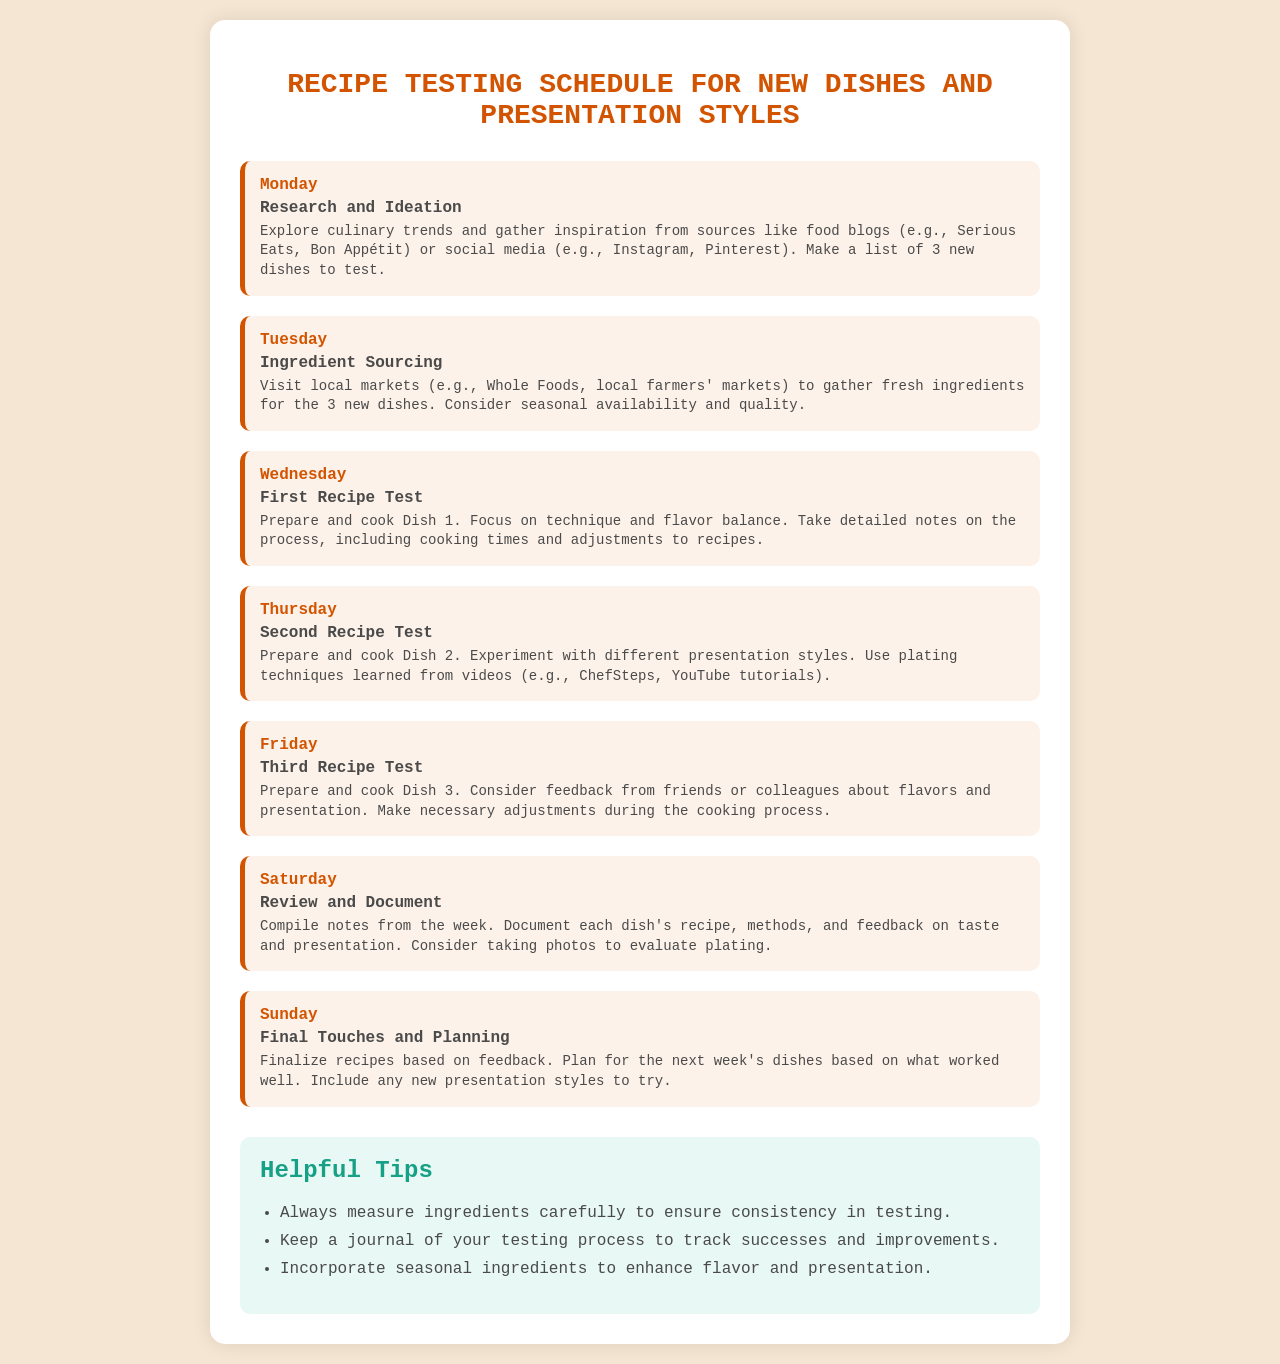What is the activity for Monday? Monday's activity is listed as "Research and Ideation," where culinary trends are explored and new dishes are planned.
Answer: Research and Ideation Which day is dedicated to sourcing ingredients? Ingredient Sourcing is scheduled for Tuesday, where fresh ingredients for new dishes are gathered.
Answer: Tuesday How many new dishes are planned for testing? The document specifies that a list of 3 new dishes is to be tested throughout the week.
Answer: 3 What is the focus on Wednesday's recipe test? The first recipe test on Wednesday focuses on technique and flavor balance for Dish 1.
Answer: Technique and flavor balance What happens on Saturday? Saturday is for reviewing and documenting notes from the week's recipe tests.
Answer: Review and Document What is the purpose of the Sunday activity? Sunday involves finalizing recipes based on feedback and planning for the next week's dishes.
Answer: Final Touches and Planning Which helpful tip emphasizes measuring? The tip advises that ingredients should be measured carefully to ensure consistency during testing.
Answer: Measure ingredients carefully What should be included when documenting each dish? The documentation should include the recipe, methods, and feedback on taste and presentation.
Answer: Recipe, methods, and feedback How do presentation styles feature in Thursday's test? On Thursday, the activity involves experimenting with different presentation styles for Dish 2.
Answer: Experiment with different presentation styles 